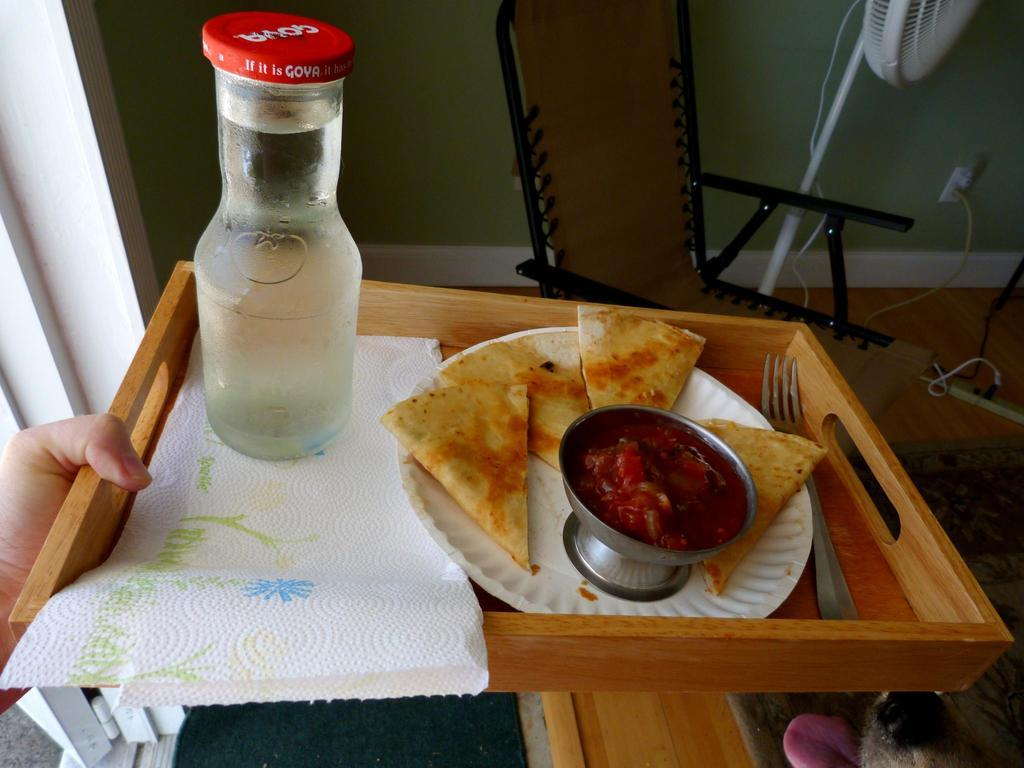<image>
Relay a brief, clear account of the picture shown. Goya brand milk goes well with quesadilla snacks. 